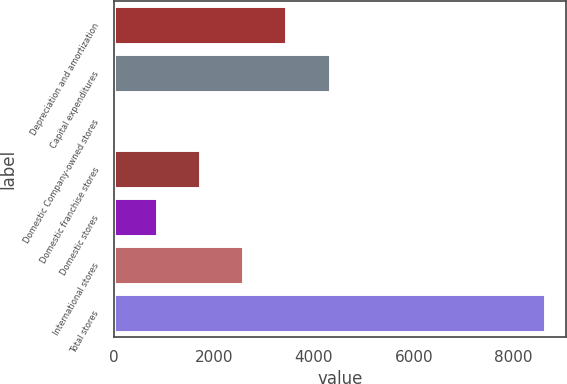Convert chart. <chart><loc_0><loc_0><loc_500><loc_500><bar_chart><fcel>Depreciation and amortization<fcel>Capital expenditures<fcel>Domestic Company-owned stores<fcel>Domestic franchise stores<fcel>Domestic stores<fcel>International stores<fcel>Total stores<nl><fcel>3450.2<fcel>4312.5<fcel>1<fcel>1725.6<fcel>863.3<fcel>2587.9<fcel>8624<nl></chart> 